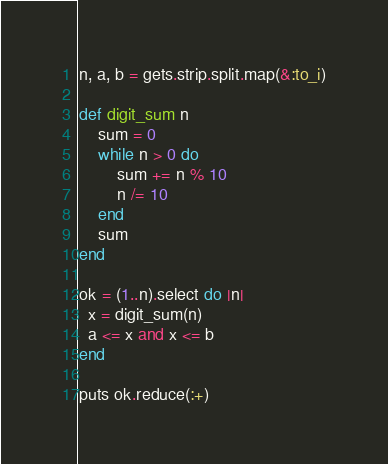Convert code to text. <code><loc_0><loc_0><loc_500><loc_500><_Ruby_>n, a, b = gets.strip.split.map(&:to_i)

def digit_sum n
    sum = 0
    while n > 0 do
        sum += n % 10
        n /= 10
    end
    sum
end

ok = (1..n).select do |n|
  x = digit_sum(n)
  a <= x and x <= b
end

puts ok.reduce(:+)</code> 